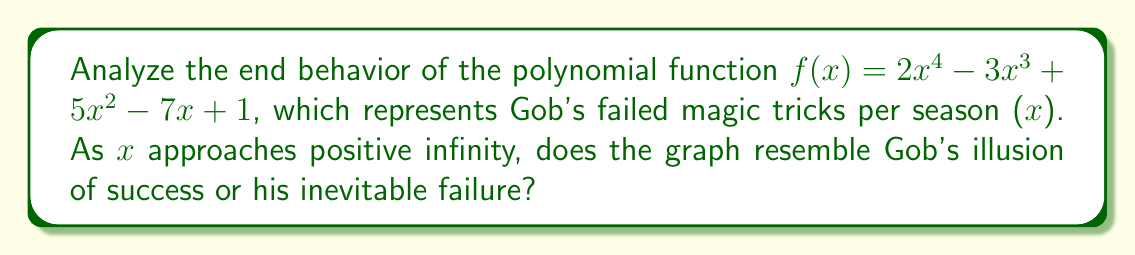Provide a solution to this math problem. To analyze the end behavior of this polynomial function, we need to focus on the leading term as x approaches infinity. Let's break it down:

1. The given polynomial is $f(x) = 2x^4 - 3x^3 + 5x^2 - 7x + 1$

2. The leading term is $2x^4$, which has:
   - Coefficient: 2 (positive)
   - Degree: 4 (even)

3. For polynomials with even degree:
   - If the leading coefficient is positive, both ends of the graph go up as x approaches ±∞
   - If the leading coefficient is negative, both ends of the graph go down as x approaches ±∞

4. In this case, the leading coefficient (2) is positive, and the degree (4) is even.

5. Therefore, as x approaches positive infinity, $f(x)$ will approach positive infinity.

6. This means the graph will go up sharply as x increases, resembling Gob's illusion of success rather than his inevitable failure.

7. However, just like Gob's magic tricks, this "success" is merely an illusion, as the function will eventually decrease for negative x values, creating a parabola-like shape.
Answer: As x → +∞, f(x) → +∞, resembling Gob's illusion of success 